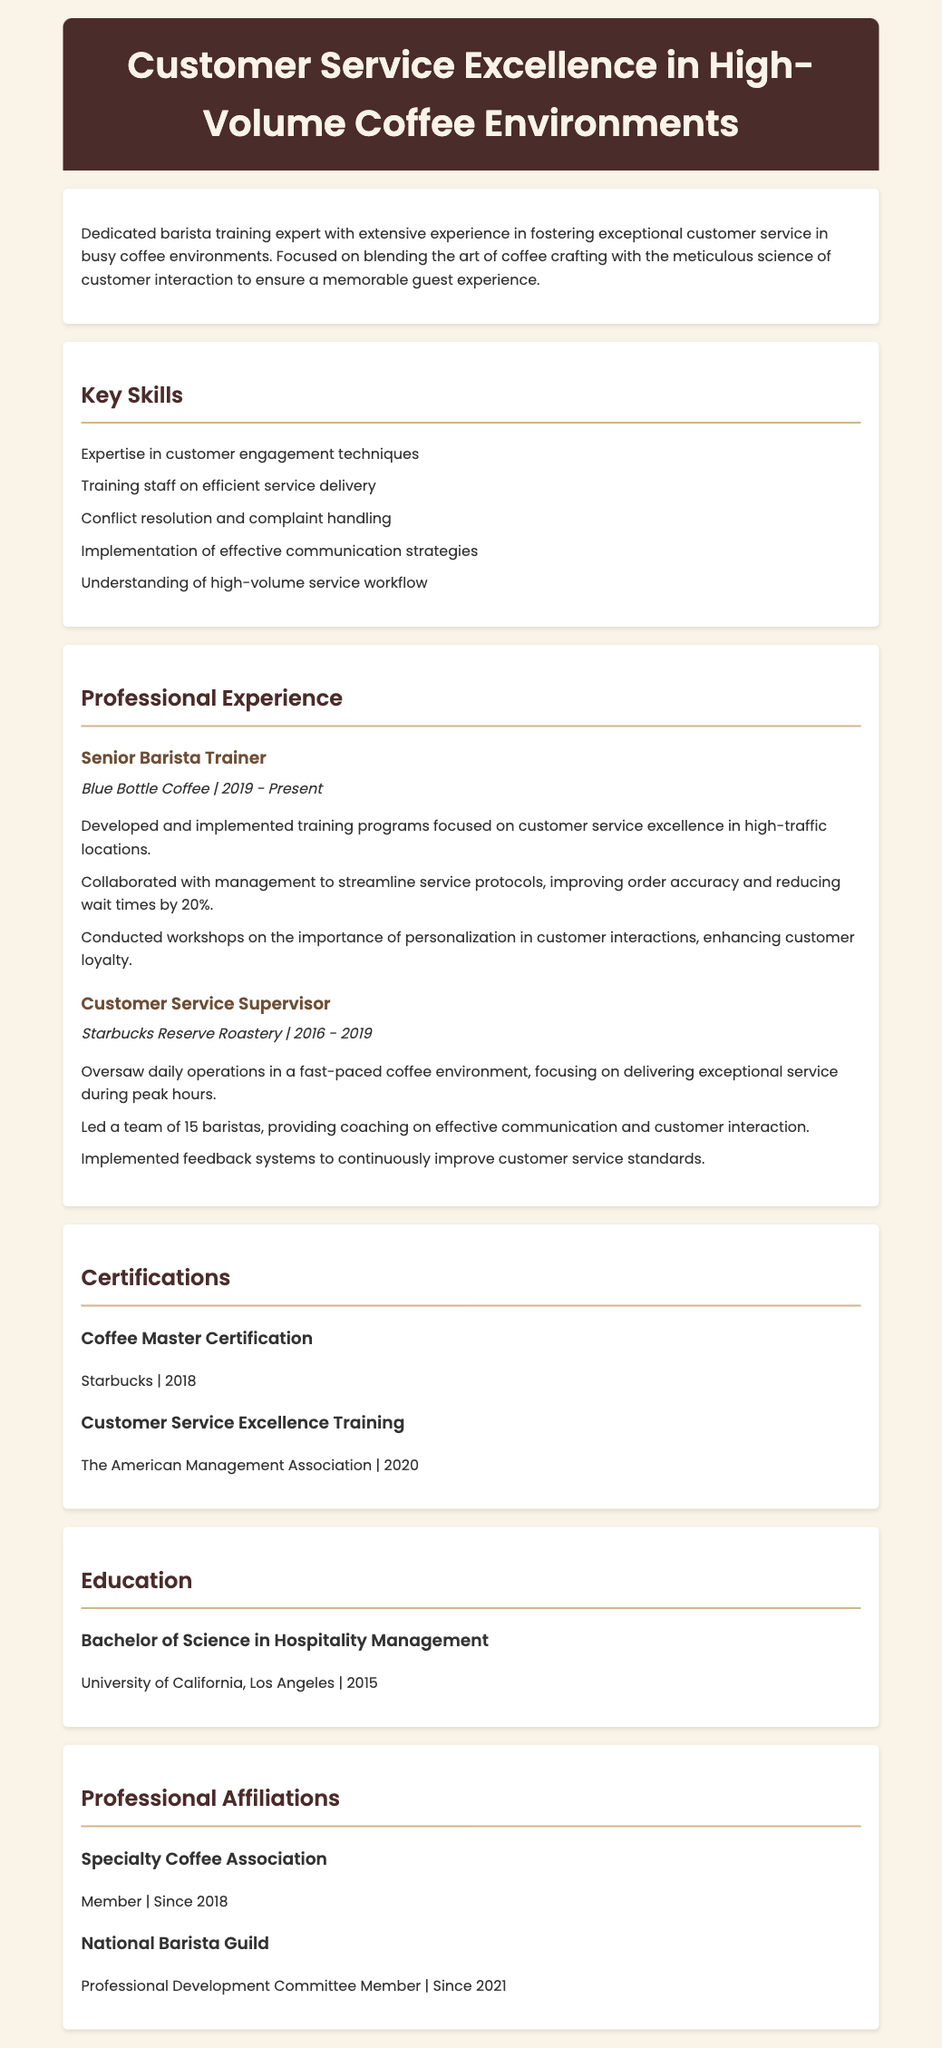what is the title of the document? The title is displayed prominently in the header of the document, indicating the focus of the Curriculum Vitae.
Answer: Customer Service Excellence in High-Volume Coffee Environments who was the Senior Barista Trainer at Blue Bottle Coffee? This position is listed under the Professional Experience section, showing the individual's role at that establishment.
Answer: Senior Barista Trainer which certification was obtained in 2018? The Certifications section lists titles and dates, where it notes the year of completion for specific certifications.
Answer: Coffee Master Certification how many years of experience does the individual have as a Customer Service Supervisor? The duration of employment in the role is specified, allowing for a quick calculation of years of experience.
Answer: 3 years what was one of the key responsibilities as a Customer Service Supervisor? Responsibilities are detailed under each position in the Professional Experience section, showcasing specific duties performed.
Answer: Oversaw daily operations in a fast-paced coffee environment what is the highest level of education achieved? The Education section specifies the degree attained by the individual, reflecting their educational background.
Answer: Bachelor of Science in Hospitality Management how many baristas were led by the Customer Service Supervisor? The document states the team's size, highlighting the individual's leadership capacity in that position.
Answer: 15 baristas which organization is the individual a member of since 2018? The Professional Affiliations section identifies organizations that the individual is involved with, along with membership dates.
Answer: Specialty Coffee Association 